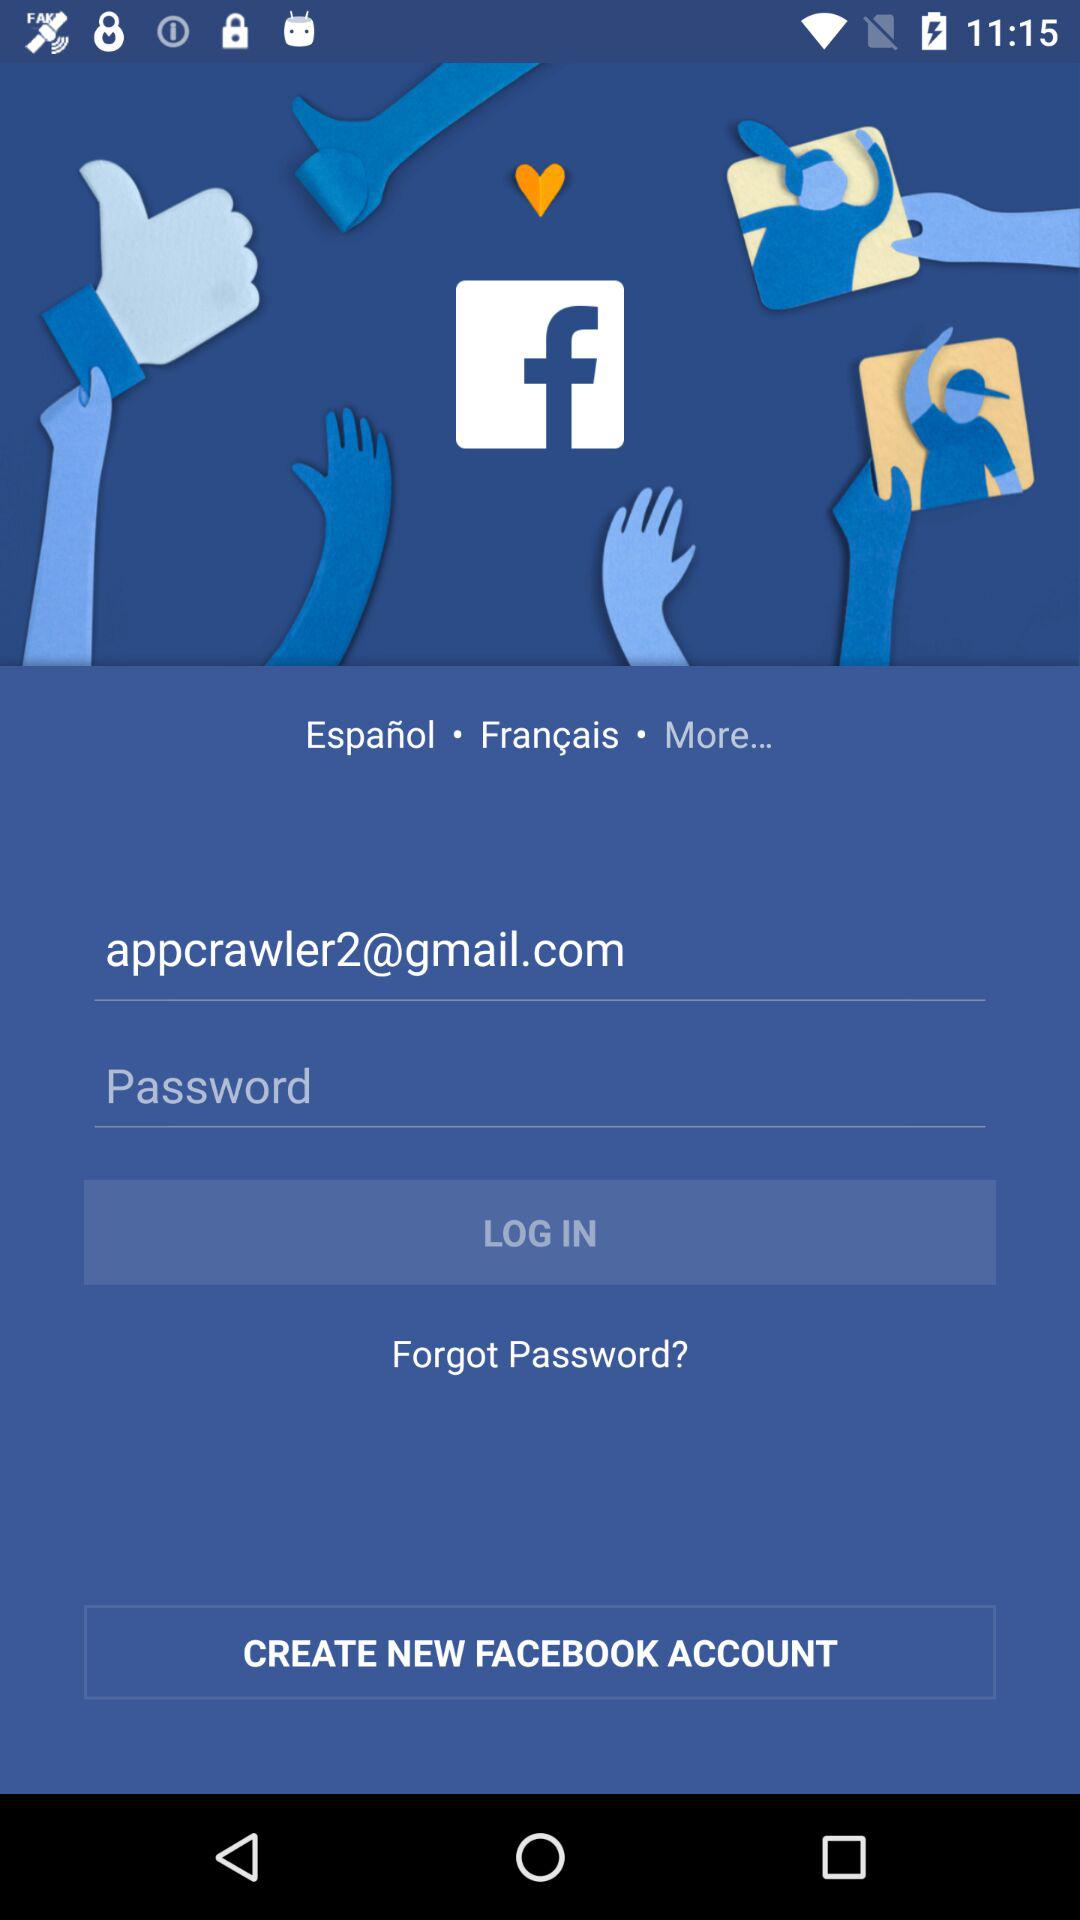What is the user name?
When the provided information is insufficient, respond with <no answer>. <no answer> 